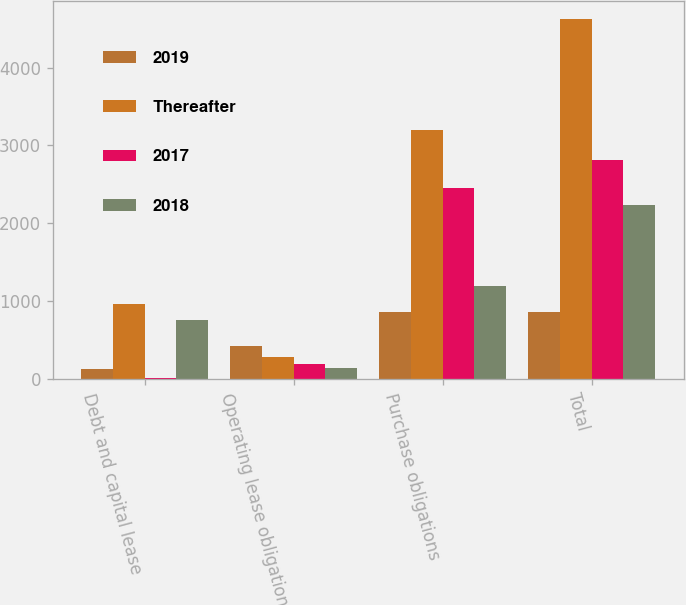<chart> <loc_0><loc_0><loc_500><loc_500><stacked_bar_chart><ecel><fcel>Debt and capital lease<fcel>Operating lease obligations<fcel>Purchase obligations<fcel>Total<nl><fcel>2019<fcel>134<fcel>430<fcel>866<fcel>866<nl><fcel>Thereafter<fcel>966<fcel>283<fcel>3204<fcel>4625<nl><fcel>2017<fcel>16<fcel>200<fcel>2458<fcel>2808<nl><fcel>2018<fcel>766<fcel>143<fcel>1197<fcel>2237<nl></chart> 